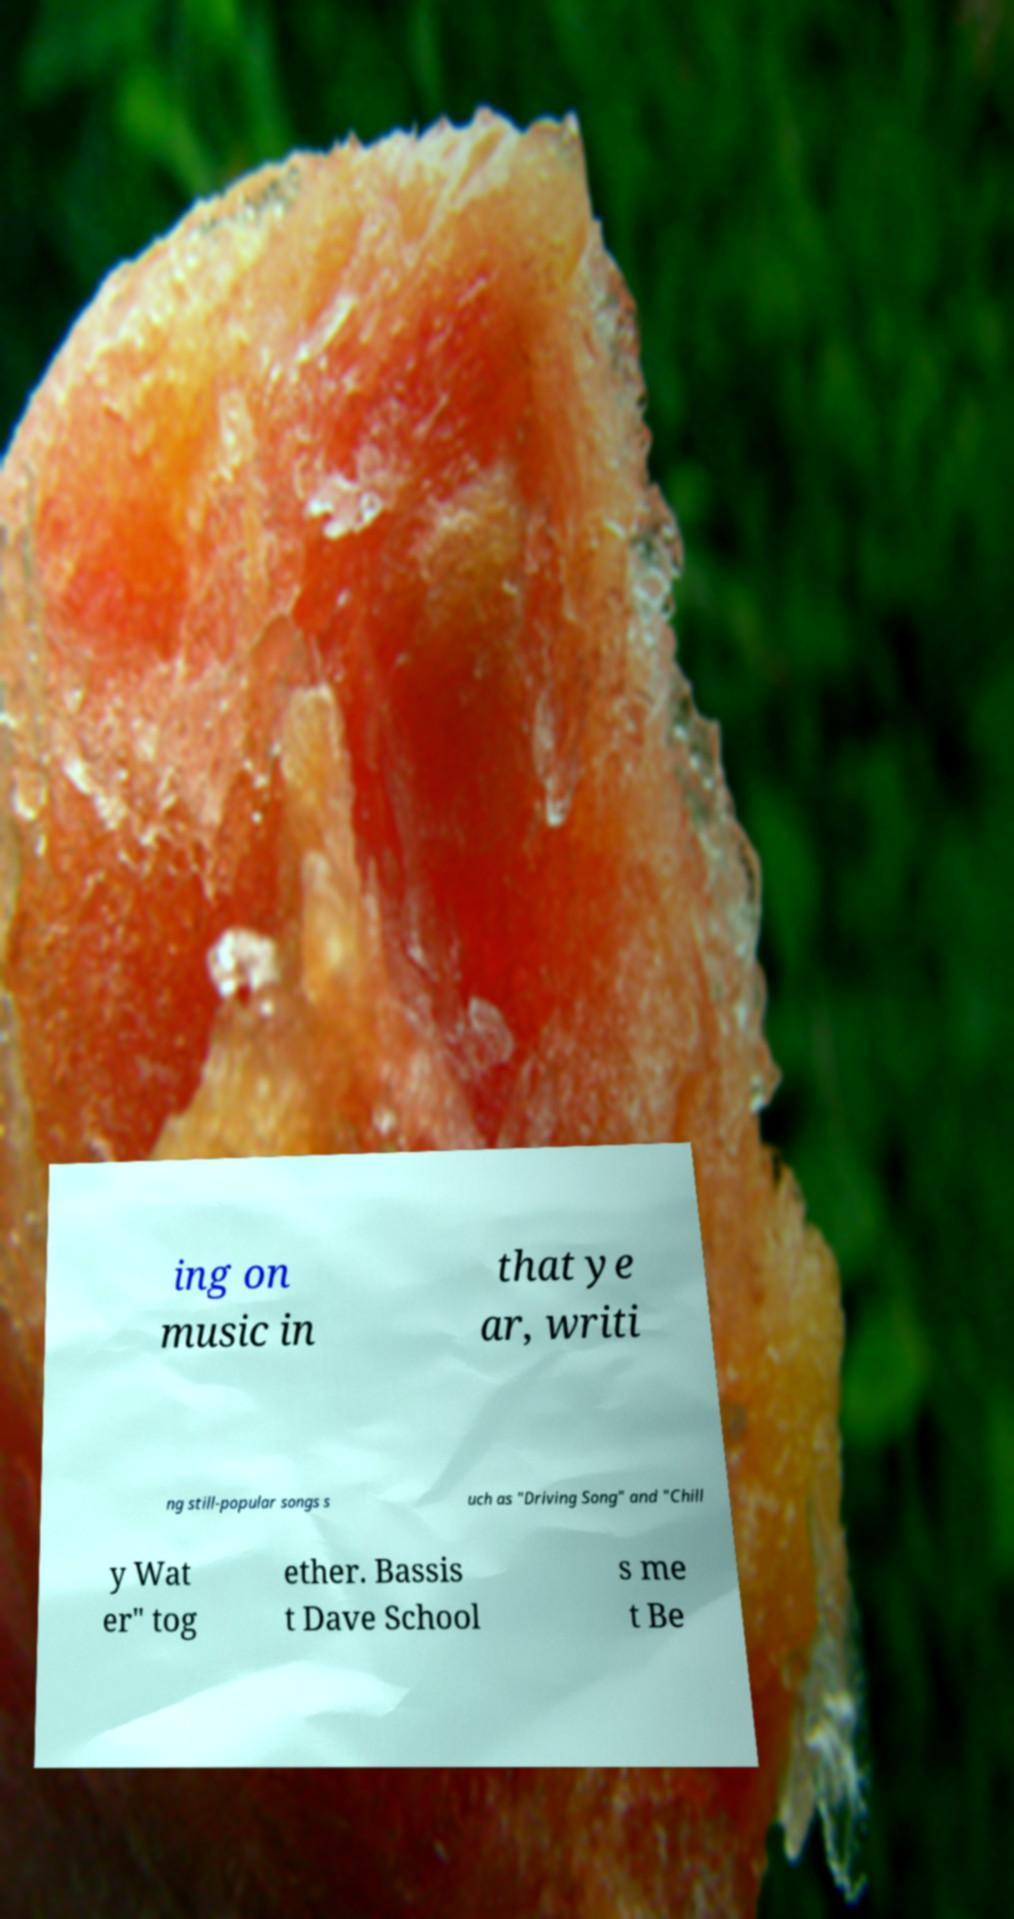Please read and relay the text visible in this image. What does it say? ing on music in that ye ar, writi ng still-popular songs s uch as "Driving Song" and "Chill y Wat er" tog ether. Bassis t Dave School s me t Be 